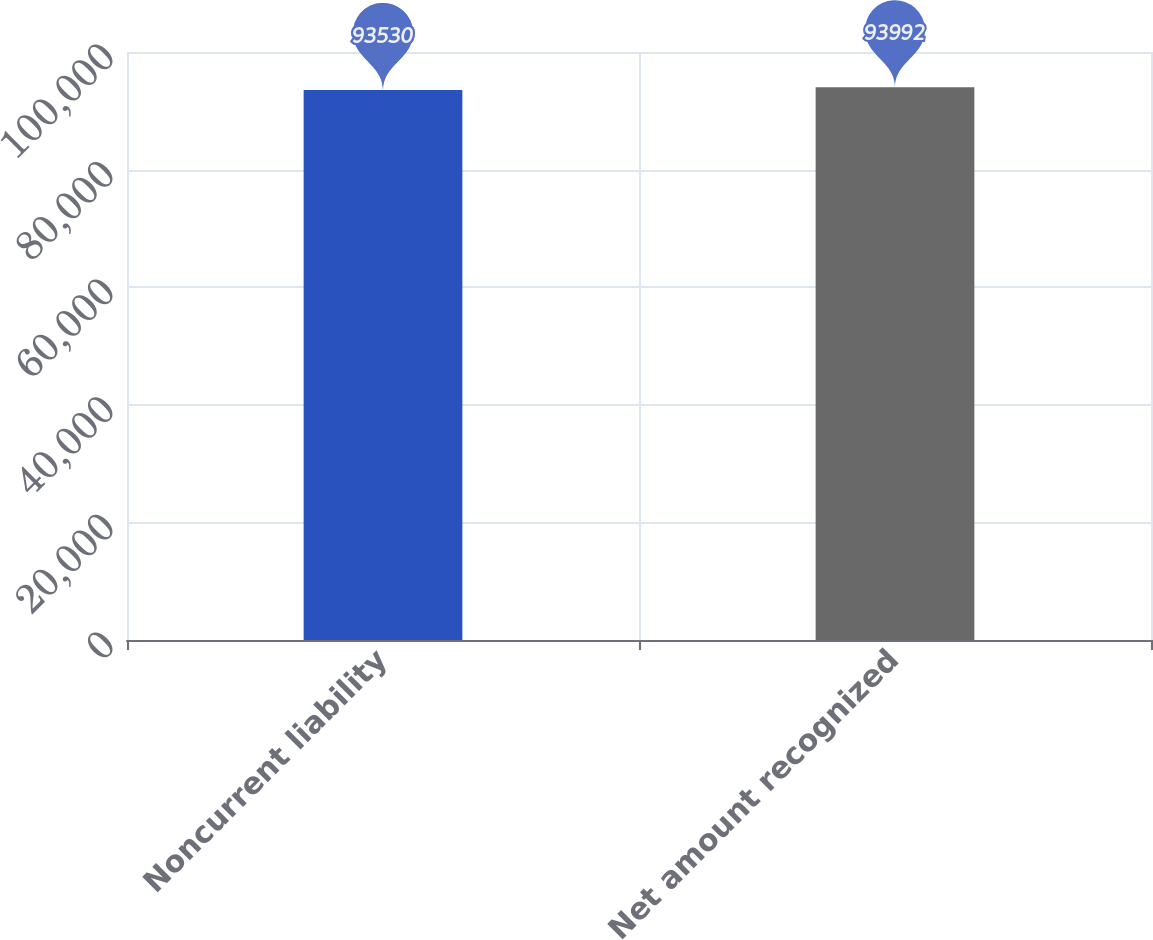<chart> <loc_0><loc_0><loc_500><loc_500><bar_chart><fcel>Noncurrent liability<fcel>Net amount recognized<nl><fcel>93530<fcel>93992<nl></chart> 